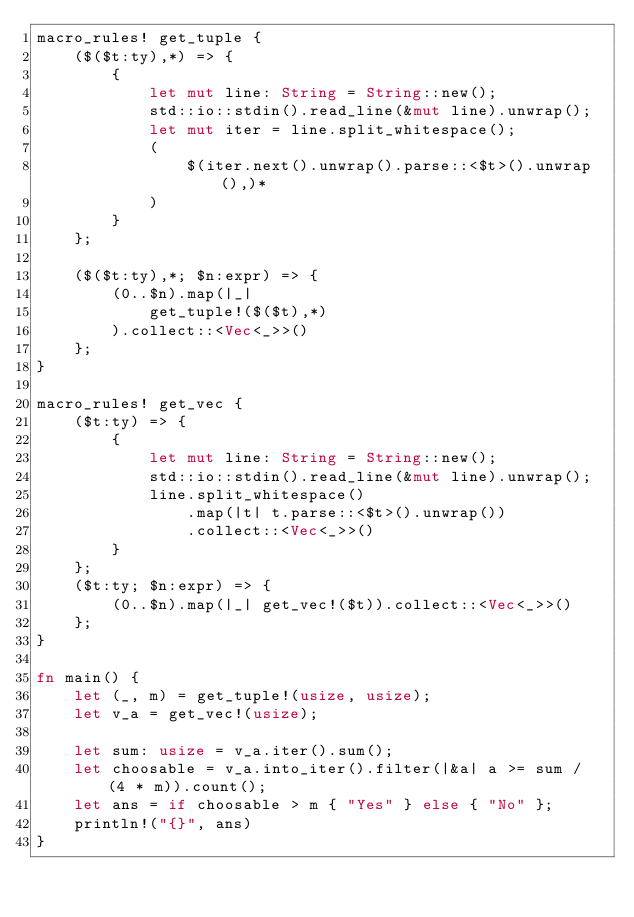Convert code to text. <code><loc_0><loc_0><loc_500><loc_500><_Rust_>macro_rules! get_tuple {
    ($($t:ty),*) => {
        {
            let mut line: String = String::new();
            std::io::stdin().read_line(&mut line).unwrap();
            let mut iter = line.split_whitespace();
            (
                $(iter.next().unwrap().parse::<$t>().unwrap(),)*
            )
        }
    };

    ($($t:ty),*; $n:expr) => {
        (0..$n).map(|_|
            get_tuple!($($t),*)
        ).collect::<Vec<_>>()
    };
}

macro_rules! get_vec {
    ($t:ty) => {
        {
            let mut line: String = String::new();
            std::io::stdin().read_line(&mut line).unwrap();
            line.split_whitespace()
                .map(|t| t.parse::<$t>().unwrap())
                .collect::<Vec<_>>()
        }
    };
    ($t:ty; $n:expr) => {
        (0..$n).map(|_| get_vec!($t)).collect::<Vec<_>>()
    };
}

fn main() {
    let (_, m) = get_tuple!(usize, usize);
    let v_a = get_vec!(usize);

    let sum: usize = v_a.iter().sum();
    let choosable = v_a.into_iter().filter(|&a| a >= sum / (4 * m)).count();
    let ans = if choosable > m { "Yes" } else { "No" };
    println!("{}", ans)
}
</code> 